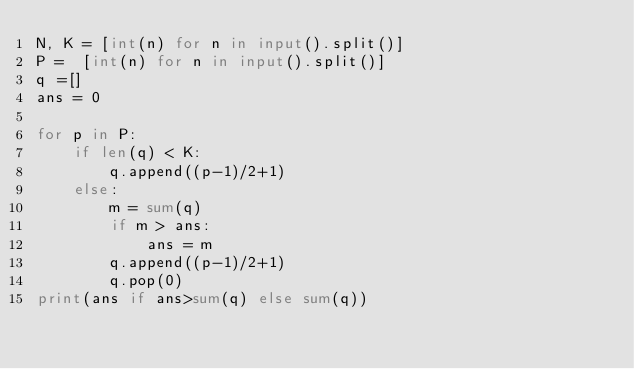Convert code to text. <code><loc_0><loc_0><loc_500><loc_500><_Python_>N, K = [int(n) for n in input().split()]
P =  [int(n) for n in input().split()]
q =[]
ans = 0

for p in P:
    if len(q) < K:
        q.append((p-1)/2+1)
    else:
        m = sum(q)
        if m > ans:
            ans = m
        q.append((p-1)/2+1)
        q.pop(0)
print(ans if ans>sum(q) else sum(q))</code> 